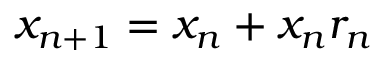Convert formula to latex. <formula><loc_0><loc_0><loc_500><loc_500>x _ { n + 1 } = x _ { n } + x _ { n } r _ { n }</formula> 